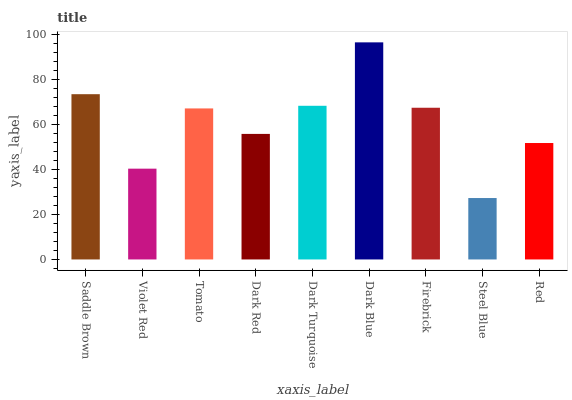Is Violet Red the minimum?
Answer yes or no. No. Is Violet Red the maximum?
Answer yes or no. No. Is Saddle Brown greater than Violet Red?
Answer yes or no. Yes. Is Violet Red less than Saddle Brown?
Answer yes or no. Yes. Is Violet Red greater than Saddle Brown?
Answer yes or no. No. Is Saddle Brown less than Violet Red?
Answer yes or no. No. Is Tomato the high median?
Answer yes or no. Yes. Is Tomato the low median?
Answer yes or no. Yes. Is Dark Blue the high median?
Answer yes or no. No. Is Steel Blue the low median?
Answer yes or no. No. 